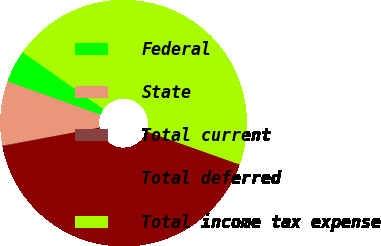Convert chart to OTSL. <chart><loc_0><loc_0><loc_500><loc_500><pie_chart><fcel>Federal<fcel>State<fcel>Total current<fcel>Total deferred<fcel>Total income tax expense<nl><fcel>4.26%<fcel>8.42%<fcel>0.11%<fcel>41.53%<fcel>45.68%<nl></chart> 